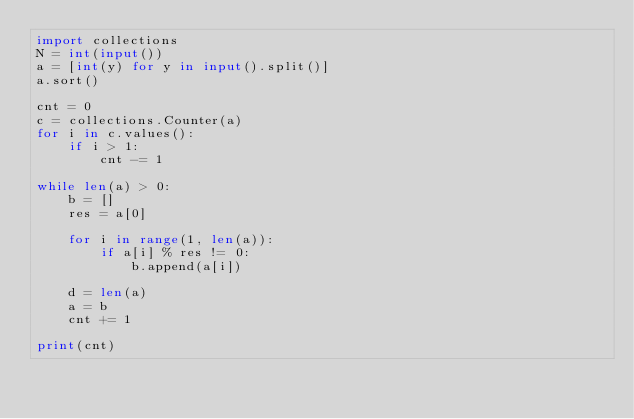Convert code to text. <code><loc_0><loc_0><loc_500><loc_500><_Python_>import collections
N = int(input())
a = [int(y) for y in input().split()]
a.sort()

cnt = 0
c = collections.Counter(a)
for i in c.values():
    if i > 1:
        cnt -= 1

while len(a) > 0:
    b = []
    res = a[0]

    for i in range(1, len(a)):
        if a[i] % res != 0:
            b.append(a[i])
    
    d = len(a)
    a = b
    cnt += 1

print(cnt)</code> 